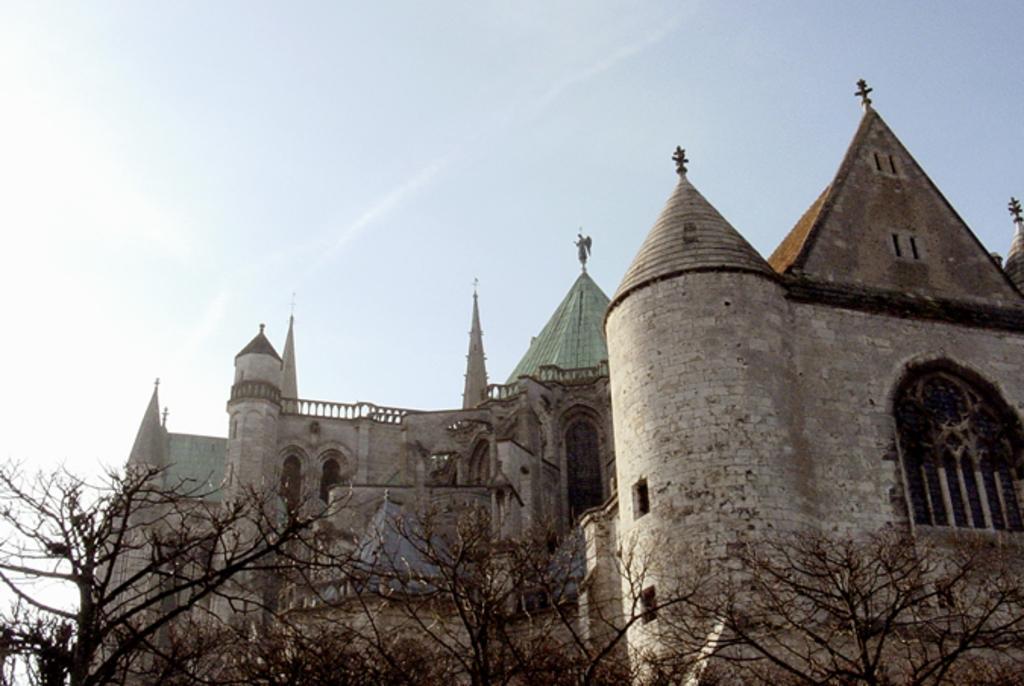Describe this image in one or two sentences. In this image I can see a building. At the bottom of the image there are some trees. On the top of the image I can see the sky. 